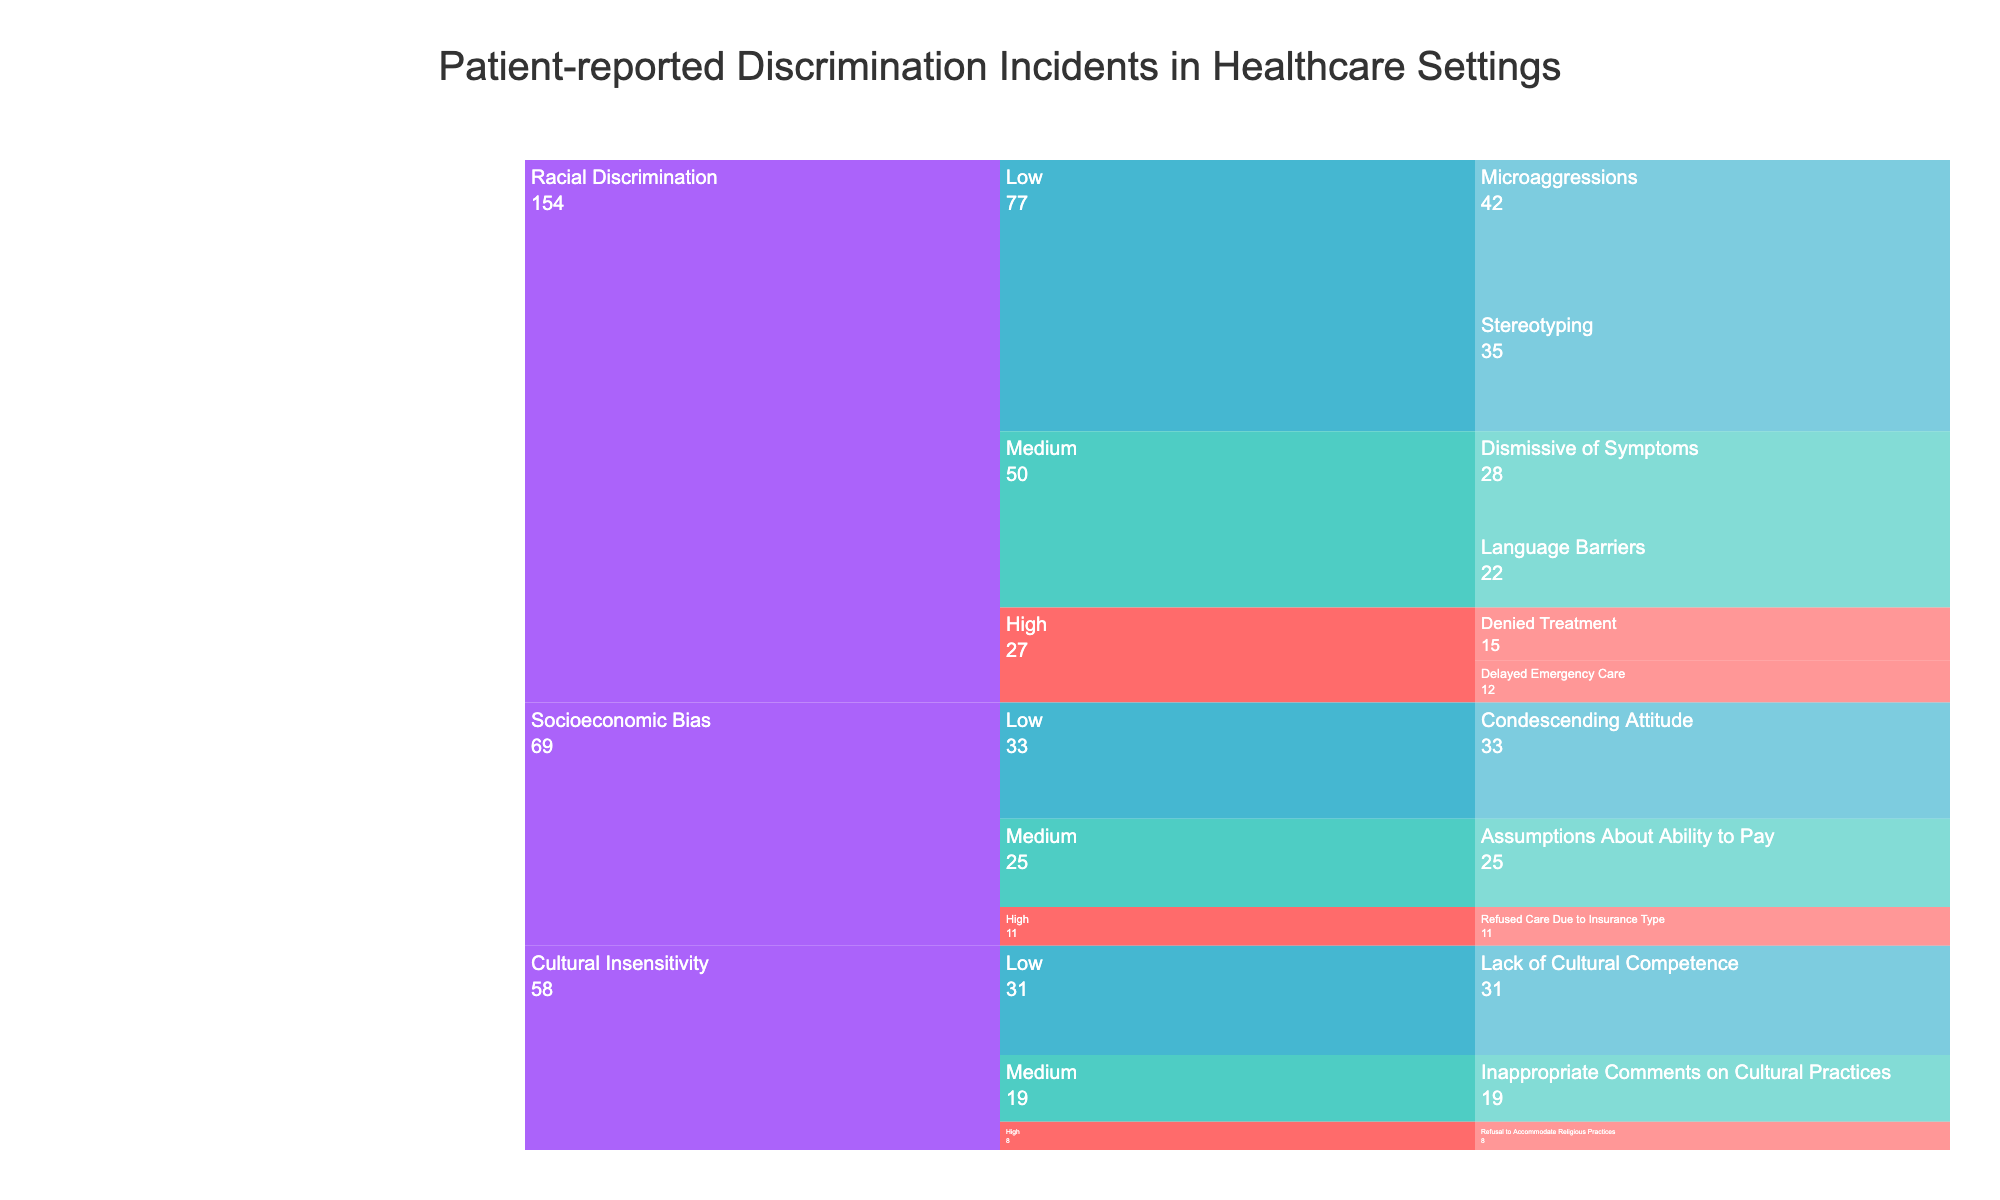What's the title of the chart? The title of the chart is centrally located at the top of the figure and is easily visible in a larger font size compared to other text elements on the chart. The title summarizes what the chart is about.
Answer: Patient-reported Discrimination Incidents in Healthcare Settings How many high-severity racial discrimination incidents are reported? To answer this, locate the 'Racial Discrimination' section, then look under 'High' severity. Sum the counts of 'Denied Treatment' and 'Delayed Emergency Care'.
Answer: 27 Which type of discrimination has the highest number of reported incidents overall? Observe the total counts of incidents under each main category ('Racial Discrimination', 'Cultural Insensitivity', 'Socioeconomic Bias'). Compare these sums.
Answer: Racial Discrimination How many incidents of cultural insensitivity have been categorized as medium severity? Look in the 'Cultural Insensitivity' section and locate the 'Medium' severity. Note the count next to 'Inappropriate Comments on Cultural Practices'.
Answer: 19 Are there more low-severity incidents of racial discrimination or socioeconomic bias? Find the 'Low' severity counts for 'Racial Discrimination' and 'Socioeconomic Bias' respectively. Compare the counts from 'Racial Discrimination' and 'Socioeconomic Bias'.
Answer: Racial Discrimination What is the total number of reported incidents of socioeconomic bias? Sum the counts of all socioeconomic bias incidents across high, medium, and low severity levels respectively: 11 (high) + 25 (medium) + 33 (low).
Answer: 69 How does the number of medium-severity incidents of racial discrimination compare to those of cultural insensitivity? Find the counts for medium-severity incidents in both categories ('Racial Discrimination' and 'Cultural Insensitivity') and compare: 28 (racial) vs 19 (cultural).
Answer: More in Racial Discrimination Which specific incident has the highest counts reported among all categories? Scan the counts associated with each specific incident in all categories and severities, and identify the highest count.
Answer: Microaggressions If you sum up all high-severity incidents across all types, what is the total count? Sum the high-severity incident counts for all three types: 27 (racial) + 8 (cultural) + 11 (socioeconomic).
Answer: 46 What percentage of total racial discrimination incidents are medium severity? First, find the total incidents for racial discrimination (15 + 12 + 28 + 22 + 35 + 42). Then, calculate the percentage of medium severity (28 + 22) within this total: (50 / 154) * 100.
Answer: ~32.5% 